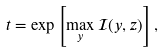<formula> <loc_0><loc_0><loc_500><loc_500>t = \exp \left [ \max _ { y } \mathcal { I } ( y , z ) \right ] ,</formula> 